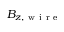<formula> <loc_0><loc_0><loc_500><loc_500>B _ { z , w i r e }</formula> 